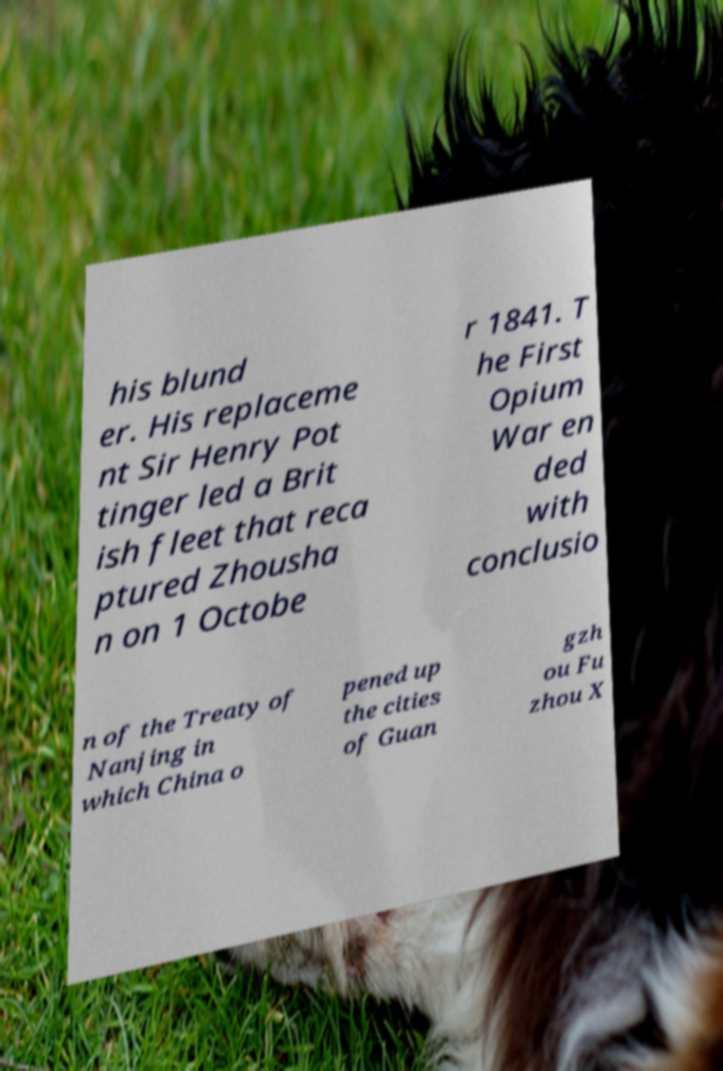What messages or text are displayed in this image? I need them in a readable, typed format. his blund er. His replaceme nt Sir Henry Pot tinger led a Brit ish fleet that reca ptured Zhousha n on 1 Octobe r 1841. T he First Opium War en ded with conclusio n of the Treaty of Nanjing in which China o pened up the cities of Guan gzh ou Fu zhou X 